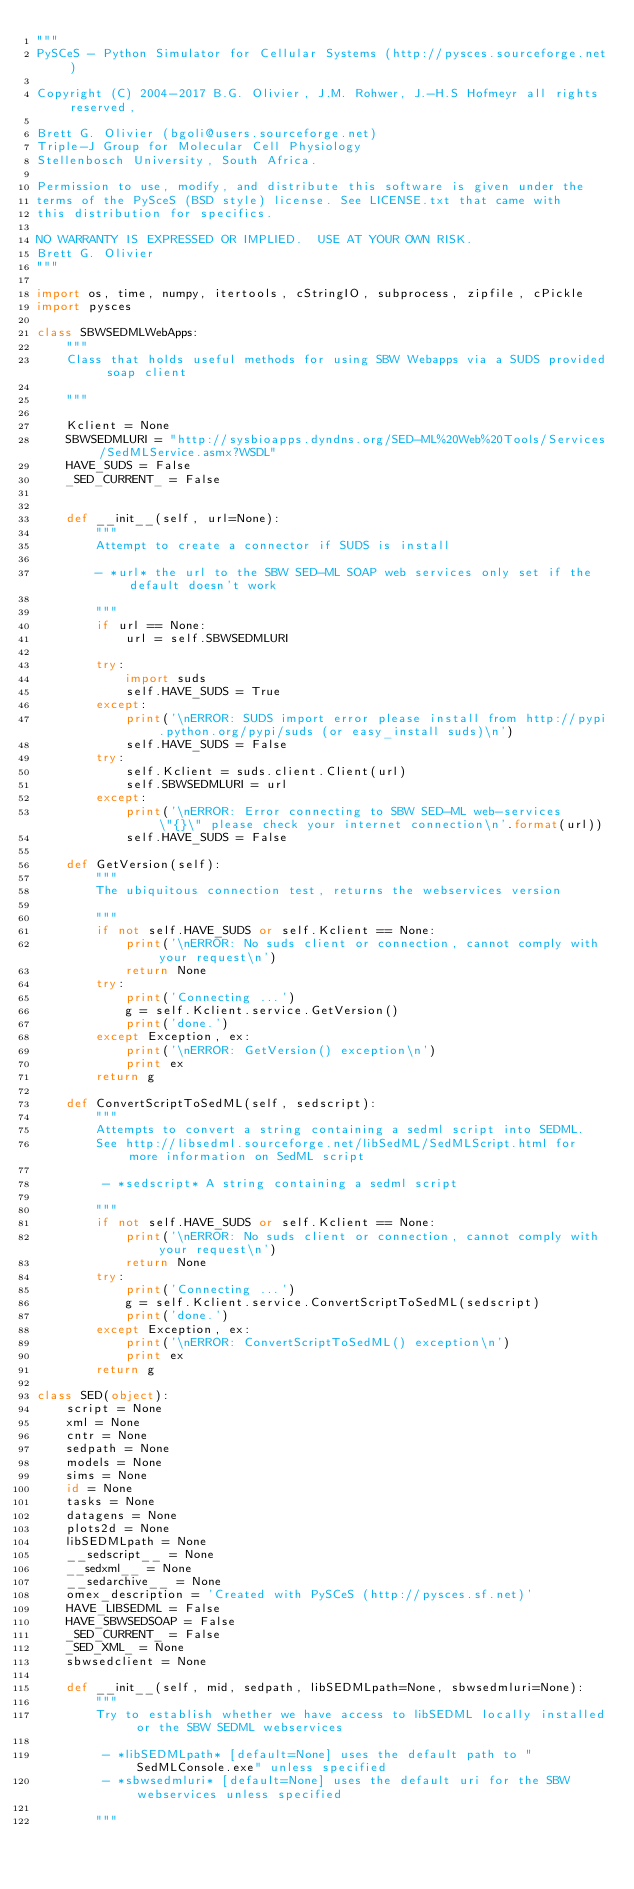Convert code to text. <code><loc_0><loc_0><loc_500><loc_500><_Python_>"""
PySCeS - Python Simulator for Cellular Systems (http://pysces.sourceforge.net)

Copyright (C) 2004-2017 B.G. Olivier, J.M. Rohwer, J.-H.S Hofmeyr all rights reserved,

Brett G. Olivier (bgoli@users.sourceforge.net)
Triple-J Group for Molecular Cell Physiology
Stellenbosch University, South Africa.

Permission to use, modify, and distribute this software is given under the
terms of the PySceS (BSD style) license. See LICENSE.txt that came with
this distribution for specifics.

NO WARRANTY IS EXPRESSED OR IMPLIED.  USE AT YOUR OWN RISK.
Brett G. Olivier
"""

import os, time, numpy, itertools, cStringIO, subprocess, zipfile, cPickle
import pysces

class SBWSEDMLWebApps:
    """
    Class that holds useful methods for using SBW Webapps via a SUDS provided soap client

    """

    Kclient = None
    SBWSEDMLURI = "http://sysbioapps.dyndns.org/SED-ML%20Web%20Tools/Services/SedMLService.asmx?WSDL"
    HAVE_SUDS = False
    _SED_CURRENT_ = False


    def __init__(self, url=None):
        """
        Attempt to create a connector if SUDS is install

        - *url* the url to the SBW SED-ML SOAP web services only set if the default doesn't work

        """
        if url == None:
            url = self.SBWSEDMLURI

        try:
            import suds
            self.HAVE_SUDS = True
        except:
            print('\nERROR: SUDS import error please install from http://pypi.python.org/pypi/suds (or easy_install suds)\n')
            self.HAVE_SUDS = False
        try:
            self.Kclient = suds.client.Client(url)
            self.SBWSEDMLURI = url
        except:
            print('\nERROR: Error connecting to SBW SED-ML web-services \"{}\" please check your internet connection\n'.format(url))
            self.HAVE_SUDS = False

    def GetVersion(self):
        """
        The ubiquitous connection test, returns the webservices version

        """
        if not self.HAVE_SUDS or self.Kclient == None:
            print('\nERROR: No suds client or connection, cannot comply with your request\n')
            return None
        try:
            print('Connecting ...')
            g = self.Kclient.service.GetVersion()
            print('done.')
        except Exception, ex:
            print('\nERROR: GetVersion() exception\n')
            print ex
        return g

    def ConvertScriptToSedML(self, sedscript):
        """
        Attempts to convert a string containing a sedml script into SEDML.
        See http://libsedml.sourceforge.net/libSedML/SedMLScript.html for more information on SedML script

         - *sedscript* A string containing a sedml script

        """
        if not self.HAVE_SUDS or self.Kclient == None:
            print('\nERROR: No suds client or connection, cannot comply with your request\n')
            return None
        try:
            print('Connecting ...')
            g = self.Kclient.service.ConvertScriptToSedML(sedscript)
            print('done.')
        except Exception, ex:
            print('\nERROR: ConvertScriptToSedML() exception\n')
            print ex
        return g

class SED(object):
    script = None
    xml = None
    cntr = None
    sedpath = None
    models = None
    sims = None
    id = None
    tasks = None
    datagens = None
    plots2d = None
    libSEDMLpath = None
    __sedscript__ = None
    __sedxml__ = None
    __sedarchive__ = None
    omex_description = 'Created with PySCeS (http://pysces.sf.net)'
    HAVE_LIBSEDML = False
    HAVE_SBWSEDSOAP = False
    _SED_CURRENT_ = False
    _SED_XML_ = None
    sbwsedclient = None

    def __init__(self, mid, sedpath, libSEDMLpath=None, sbwsedmluri=None):
        """
        Try to establish whether we have access to libSEDML locally installed or the SBW SEDML webservices

         - *libSEDMLpath* [default=None] uses the default path to "SedMLConsole.exe" unless specified
         - *sbwsedmluri* [default=None] uses the default uri for the SBW webservices unless specified

        """</code> 